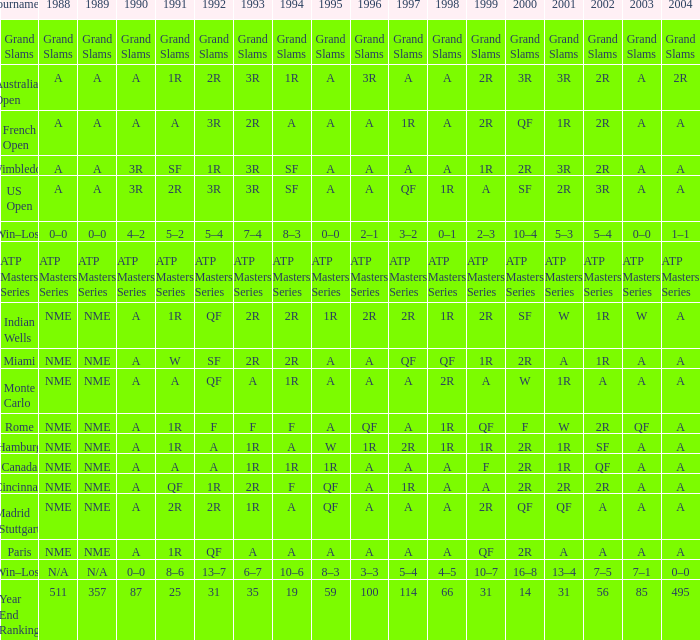What shows for 1995 when 1996 shows grand slams? Grand Slams. 